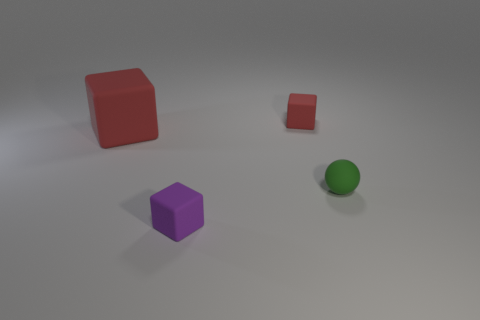Add 1 small green matte objects. How many objects exist? 5 Subtract all spheres. How many objects are left? 3 Subtract all large red cylinders. Subtract all tiny rubber blocks. How many objects are left? 2 Add 4 purple rubber cubes. How many purple rubber cubes are left? 5 Add 3 tiny yellow metallic cubes. How many tiny yellow metallic cubes exist? 3 Subtract 0 yellow cylinders. How many objects are left? 4 